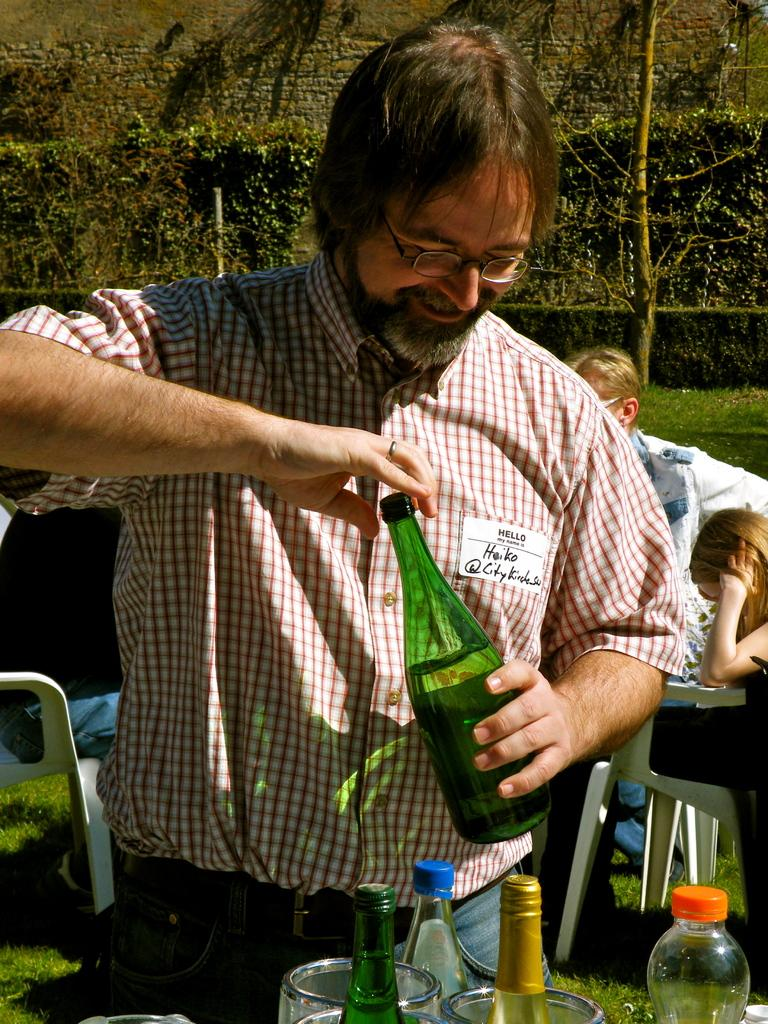What is the main subject of the image? There is a man in the image. What is the man holding in the image? The man is holding a bottle. Can you describe the setting of the image? There are chairs in the garden, and there are trees at the back side of the image. What type of war is depicted in the image? There is no war depicted in the image; it features a man holding a bottle in a garden setting. How many bees can be seen buzzing around the man in the image? There are no bees present in the image. 